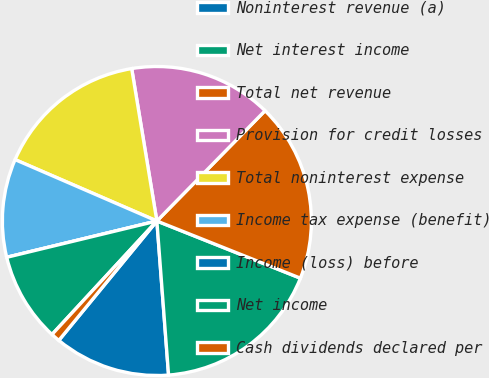<chart> <loc_0><loc_0><loc_500><loc_500><pie_chart><fcel>Noninterest revenue (a)<fcel>Net interest income<fcel>Total net revenue<fcel>Provision for credit losses<fcel>Total noninterest expense<fcel>Income tax expense (benefit)<fcel>Income (loss) before<fcel>Net income<fcel>Cash dividends declared per<nl><fcel>12.15%<fcel>17.76%<fcel>18.69%<fcel>14.95%<fcel>15.89%<fcel>10.28%<fcel>0.0%<fcel>9.35%<fcel>0.93%<nl></chart> 